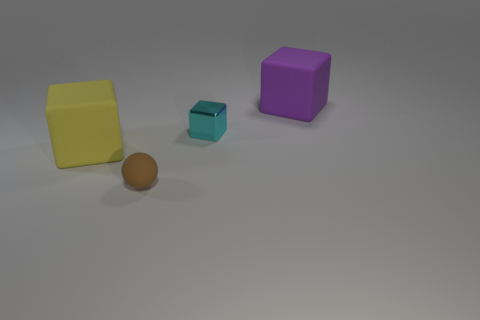What could be the size of the room given the shadows of the objects? It's not possible to determine the exact size of the room based on the shadows alone, as it depends on the light source's position and intensity. However, given that the shadows are fairly soft and not too elongated, the light source might be fairly close, suggesting a smaller room or a setup in a controlled environment such as a studio. 